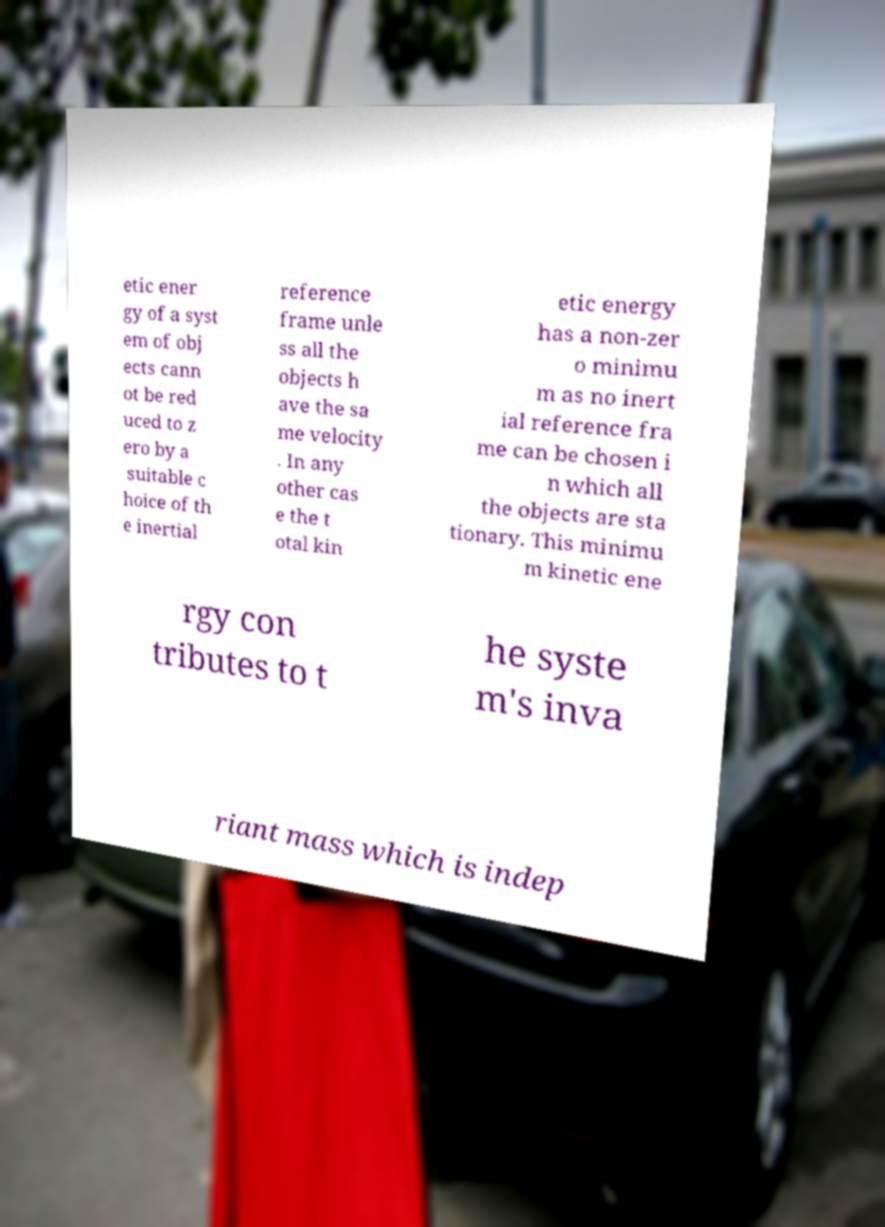Could you extract and type out the text from this image? etic ener gy of a syst em of obj ects cann ot be red uced to z ero by a suitable c hoice of th e inertial reference frame unle ss all the objects h ave the sa me velocity . In any other cas e the t otal kin etic energy has a non-zer o minimu m as no inert ial reference fra me can be chosen i n which all the objects are sta tionary. This minimu m kinetic ene rgy con tributes to t he syste m's inva riant mass which is indep 